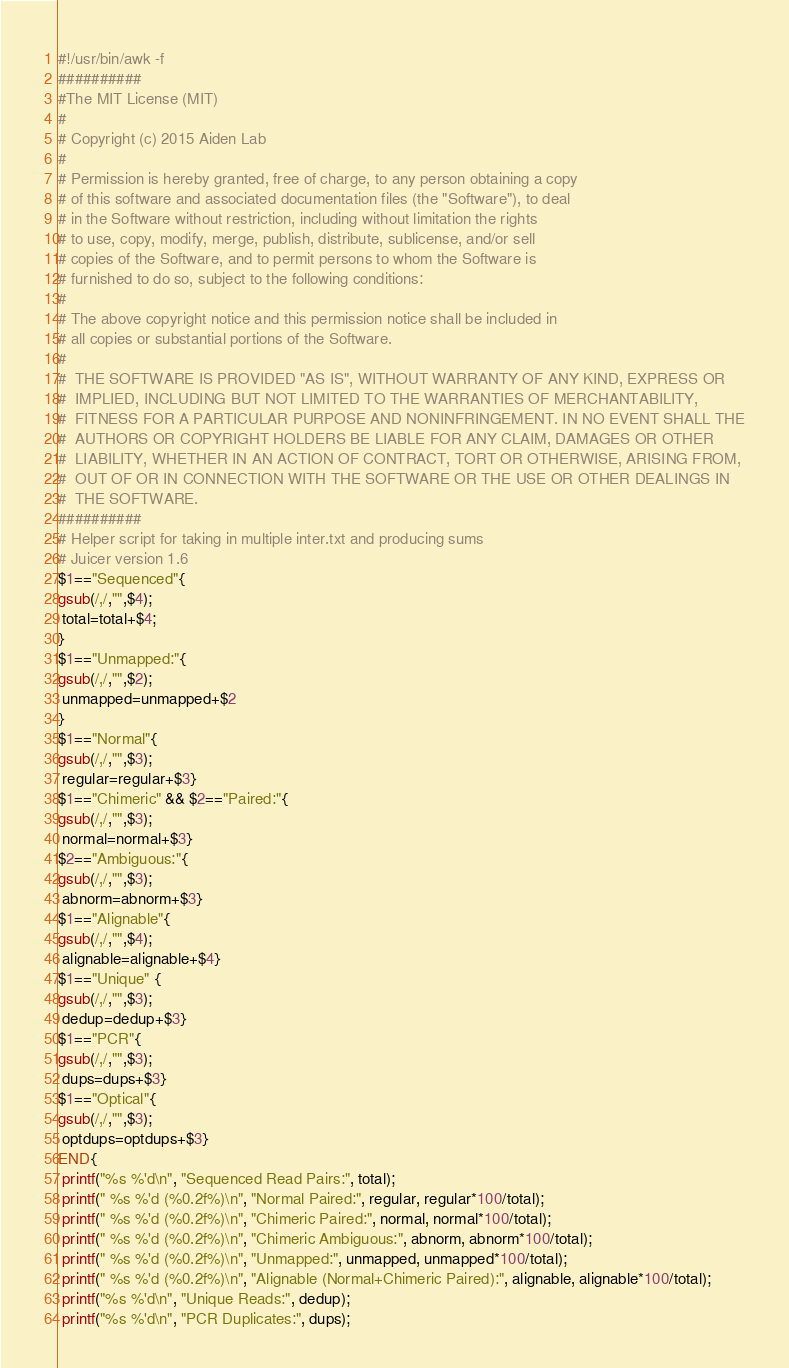<code> <loc_0><loc_0><loc_500><loc_500><_Awk_>#!/usr/bin/awk -f
##########
#The MIT License (MIT)
#
# Copyright (c) 2015 Aiden Lab
#
# Permission is hereby granted, free of charge, to any person obtaining a copy
# of this software and associated documentation files (the "Software"), to deal
# in the Software without restriction, including without limitation the rights
# to use, copy, modify, merge, publish, distribute, sublicense, and/or sell
# copies of the Software, and to permit persons to whom the Software is
# furnished to do so, subject to the following conditions:
#
# The above copyright notice and this permission notice shall be included in
# all copies or substantial portions of the Software.
#
#  THE SOFTWARE IS PROVIDED "AS IS", WITHOUT WARRANTY OF ANY KIND, EXPRESS OR
#  IMPLIED, INCLUDING BUT NOT LIMITED TO THE WARRANTIES OF MERCHANTABILITY,
#  FITNESS FOR A PARTICULAR PURPOSE AND NONINFRINGEMENT. IN NO EVENT SHALL THE
#  AUTHORS OR COPYRIGHT HOLDERS BE LIABLE FOR ANY CLAIM, DAMAGES OR OTHER
#  LIABILITY, WHETHER IN AN ACTION OF CONTRACT, TORT OR OTHERWISE, ARISING FROM,
#  OUT OF OR IN CONNECTION WITH THE SOFTWARE OR THE USE OR OTHER DEALINGS IN
#  THE SOFTWARE.
##########
# Helper script for taking in multiple inter.txt and producing sums
# Juicer version 1.6
$1=="Sequenced"{
gsub(/,/,"",$4);
 total=total+$4;
}
$1=="Unmapped:"{
gsub(/,/,"",$2);
 unmapped=unmapped+$2
}
$1=="Normal"{
gsub(/,/,"",$3);
 regular=regular+$3}
$1=="Chimeric" && $2=="Paired:"{
gsub(/,/,"",$3);
 normal=normal+$3}
$2=="Ambiguous:"{
gsub(/,/,"",$3);
 abnorm=abnorm+$3}
$1=="Alignable"{
gsub(/,/,"",$4);
 alignable=alignable+$4}
$1=="Unique" {
gsub(/,/,"",$3);
 dedup=dedup+$3}
$1=="PCR"{
gsub(/,/,"",$3);
 dups=dups+$3}
$1=="Optical"{
gsub(/,/,"",$3);
 optdups=optdups+$3}
END{
 printf("%s %'d\n", "Sequenced Read Pairs:", total);
 printf(" %s %'d (%0.2f%)\n", "Normal Paired:", regular, regular*100/total);
 printf(" %s %'d (%0.2f%)\n", "Chimeric Paired:", normal, normal*100/total);
 printf(" %s %'d (%0.2f%)\n", "Chimeric Ambiguous:", abnorm, abnorm*100/total);
 printf(" %s %'d (%0.2f%)\n", "Unmapped:", unmapped, unmapped*100/total);
 printf(" %s %'d (%0.2f%)\n", "Alignable (Normal+Chimeric Paired):", alignable, alignable*100/total);
 printf("%s %'d\n", "Unique Reads:", dedup);
 printf("%s %'d\n", "PCR Duplicates:", dups);</code> 